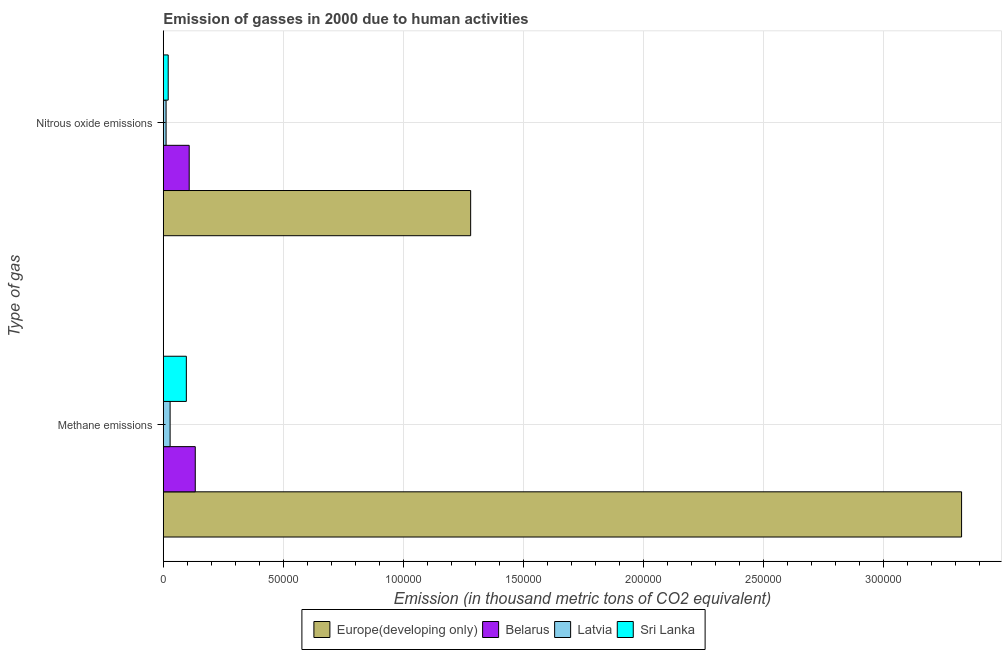Are the number of bars per tick equal to the number of legend labels?
Offer a very short reply. Yes. How many bars are there on the 2nd tick from the top?
Make the answer very short. 4. How many bars are there on the 1st tick from the bottom?
Offer a terse response. 4. What is the label of the 1st group of bars from the top?
Make the answer very short. Nitrous oxide emissions. What is the amount of nitrous oxide emissions in Belarus?
Your answer should be very brief. 1.08e+04. Across all countries, what is the maximum amount of nitrous oxide emissions?
Provide a succinct answer. 1.28e+05. Across all countries, what is the minimum amount of methane emissions?
Offer a very short reply. 2840. In which country was the amount of nitrous oxide emissions maximum?
Provide a succinct answer. Europe(developing only). In which country was the amount of nitrous oxide emissions minimum?
Your answer should be compact. Latvia. What is the total amount of methane emissions in the graph?
Offer a very short reply. 3.59e+05. What is the difference between the amount of methane emissions in Sri Lanka and that in Latvia?
Offer a terse response. 6767.2. What is the difference between the amount of nitrous oxide emissions in Europe(developing only) and the amount of methane emissions in Latvia?
Your answer should be very brief. 1.25e+05. What is the average amount of nitrous oxide emissions per country?
Your answer should be compact. 3.55e+04. What is the difference between the amount of methane emissions and amount of nitrous oxide emissions in Europe(developing only)?
Ensure brevity in your answer.  2.05e+05. In how many countries, is the amount of methane emissions greater than 220000 thousand metric tons?
Your response must be concise. 1. What is the ratio of the amount of methane emissions in Latvia to that in Belarus?
Your answer should be compact. 0.21. What does the 3rd bar from the top in Nitrous oxide emissions represents?
Provide a short and direct response. Belarus. What does the 2nd bar from the bottom in Nitrous oxide emissions represents?
Ensure brevity in your answer.  Belarus. How many bars are there?
Your answer should be very brief. 8. What is the difference between two consecutive major ticks on the X-axis?
Make the answer very short. 5.00e+04. Are the values on the major ticks of X-axis written in scientific E-notation?
Offer a very short reply. No. How many legend labels are there?
Keep it short and to the point. 4. How are the legend labels stacked?
Provide a short and direct response. Horizontal. What is the title of the graph?
Your answer should be very brief. Emission of gasses in 2000 due to human activities. Does "Iraq" appear as one of the legend labels in the graph?
Provide a succinct answer. No. What is the label or title of the X-axis?
Your answer should be compact. Emission (in thousand metric tons of CO2 equivalent). What is the label or title of the Y-axis?
Provide a succinct answer. Type of gas. What is the Emission (in thousand metric tons of CO2 equivalent) in Europe(developing only) in Methane emissions?
Offer a terse response. 3.33e+05. What is the Emission (in thousand metric tons of CO2 equivalent) in Belarus in Methane emissions?
Give a very brief answer. 1.33e+04. What is the Emission (in thousand metric tons of CO2 equivalent) of Latvia in Methane emissions?
Provide a short and direct response. 2840. What is the Emission (in thousand metric tons of CO2 equivalent) in Sri Lanka in Methane emissions?
Your response must be concise. 9607.2. What is the Emission (in thousand metric tons of CO2 equivalent) of Europe(developing only) in Nitrous oxide emissions?
Your answer should be compact. 1.28e+05. What is the Emission (in thousand metric tons of CO2 equivalent) in Belarus in Nitrous oxide emissions?
Provide a succinct answer. 1.08e+04. What is the Emission (in thousand metric tons of CO2 equivalent) in Latvia in Nitrous oxide emissions?
Provide a short and direct response. 1159.4. What is the Emission (in thousand metric tons of CO2 equivalent) of Sri Lanka in Nitrous oxide emissions?
Your answer should be compact. 2044.5. Across all Type of gas, what is the maximum Emission (in thousand metric tons of CO2 equivalent) in Europe(developing only)?
Provide a short and direct response. 3.33e+05. Across all Type of gas, what is the maximum Emission (in thousand metric tons of CO2 equivalent) of Belarus?
Your answer should be very brief. 1.33e+04. Across all Type of gas, what is the maximum Emission (in thousand metric tons of CO2 equivalent) of Latvia?
Offer a terse response. 2840. Across all Type of gas, what is the maximum Emission (in thousand metric tons of CO2 equivalent) in Sri Lanka?
Provide a short and direct response. 9607.2. Across all Type of gas, what is the minimum Emission (in thousand metric tons of CO2 equivalent) of Europe(developing only)?
Provide a succinct answer. 1.28e+05. Across all Type of gas, what is the minimum Emission (in thousand metric tons of CO2 equivalent) in Belarus?
Keep it short and to the point. 1.08e+04. Across all Type of gas, what is the minimum Emission (in thousand metric tons of CO2 equivalent) in Latvia?
Give a very brief answer. 1159.4. Across all Type of gas, what is the minimum Emission (in thousand metric tons of CO2 equivalent) in Sri Lanka?
Ensure brevity in your answer.  2044.5. What is the total Emission (in thousand metric tons of CO2 equivalent) of Europe(developing only) in the graph?
Ensure brevity in your answer.  4.61e+05. What is the total Emission (in thousand metric tons of CO2 equivalent) of Belarus in the graph?
Offer a terse response. 2.41e+04. What is the total Emission (in thousand metric tons of CO2 equivalent) in Latvia in the graph?
Your answer should be very brief. 3999.4. What is the total Emission (in thousand metric tons of CO2 equivalent) of Sri Lanka in the graph?
Keep it short and to the point. 1.17e+04. What is the difference between the Emission (in thousand metric tons of CO2 equivalent) of Europe(developing only) in Methane emissions and that in Nitrous oxide emissions?
Ensure brevity in your answer.  2.05e+05. What is the difference between the Emission (in thousand metric tons of CO2 equivalent) of Belarus in Methane emissions and that in Nitrous oxide emissions?
Offer a terse response. 2527.5. What is the difference between the Emission (in thousand metric tons of CO2 equivalent) in Latvia in Methane emissions and that in Nitrous oxide emissions?
Offer a terse response. 1680.6. What is the difference between the Emission (in thousand metric tons of CO2 equivalent) of Sri Lanka in Methane emissions and that in Nitrous oxide emissions?
Give a very brief answer. 7562.7. What is the difference between the Emission (in thousand metric tons of CO2 equivalent) in Europe(developing only) in Methane emissions and the Emission (in thousand metric tons of CO2 equivalent) in Belarus in Nitrous oxide emissions?
Your response must be concise. 3.22e+05. What is the difference between the Emission (in thousand metric tons of CO2 equivalent) of Europe(developing only) in Methane emissions and the Emission (in thousand metric tons of CO2 equivalent) of Latvia in Nitrous oxide emissions?
Make the answer very short. 3.32e+05. What is the difference between the Emission (in thousand metric tons of CO2 equivalent) of Europe(developing only) in Methane emissions and the Emission (in thousand metric tons of CO2 equivalent) of Sri Lanka in Nitrous oxide emissions?
Your response must be concise. 3.31e+05. What is the difference between the Emission (in thousand metric tons of CO2 equivalent) in Belarus in Methane emissions and the Emission (in thousand metric tons of CO2 equivalent) in Latvia in Nitrous oxide emissions?
Give a very brief answer. 1.22e+04. What is the difference between the Emission (in thousand metric tons of CO2 equivalent) of Belarus in Methane emissions and the Emission (in thousand metric tons of CO2 equivalent) of Sri Lanka in Nitrous oxide emissions?
Give a very brief answer. 1.13e+04. What is the difference between the Emission (in thousand metric tons of CO2 equivalent) of Latvia in Methane emissions and the Emission (in thousand metric tons of CO2 equivalent) of Sri Lanka in Nitrous oxide emissions?
Offer a very short reply. 795.5. What is the average Emission (in thousand metric tons of CO2 equivalent) in Europe(developing only) per Type of gas?
Give a very brief answer. 2.30e+05. What is the average Emission (in thousand metric tons of CO2 equivalent) of Belarus per Type of gas?
Give a very brief answer. 1.21e+04. What is the average Emission (in thousand metric tons of CO2 equivalent) of Latvia per Type of gas?
Provide a succinct answer. 1999.7. What is the average Emission (in thousand metric tons of CO2 equivalent) in Sri Lanka per Type of gas?
Offer a terse response. 5825.85. What is the difference between the Emission (in thousand metric tons of CO2 equivalent) in Europe(developing only) and Emission (in thousand metric tons of CO2 equivalent) in Belarus in Methane emissions?
Your answer should be very brief. 3.19e+05. What is the difference between the Emission (in thousand metric tons of CO2 equivalent) of Europe(developing only) and Emission (in thousand metric tons of CO2 equivalent) of Latvia in Methane emissions?
Provide a succinct answer. 3.30e+05. What is the difference between the Emission (in thousand metric tons of CO2 equivalent) of Europe(developing only) and Emission (in thousand metric tons of CO2 equivalent) of Sri Lanka in Methane emissions?
Keep it short and to the point. 3.23e+05. What is the difference between the Emission (in thousand metric tons of CO2 equivalent) of Belarus and Emission (in thousand metric tons of CO2 equivalent) of Latvia in Methane emissions?
Offer a terse response. 1.05e+04. What is the difference between the Emission (in thousand metric tons of CO2 equivalent) of Belarus and Emission (in thousand metric tons of CO2 equivalent) of Sri Lanka in Methane emissions?
Offer a terse response. 3716.2. What is the difference between the Emission (in thousand metric tons of CO2 equivalent) of Latvia and Emission (in thousand metric tons of CO2 equivalent) of Sri Lanka in Methane emissions?
Ensure brevity in your answer.  -6767.2. What is the difference between the Emission (in thousand metric tons of CO2 equivalent) of Europe(developing only) and Emission (in thousand metric tons of CO2 equivalent) of Belarus in Nitrous oxide emissions?
Make the answer very short. 1.17e+05. What is the difference between the Emission (in thousand metric tons of CO2 equivalent) of Europe(developing only) and Emission (in thousand metric tons of CO2 equivalent) of Latvia in Nitrous oxide emissions?
Give a very brief answer. 1.27e+05. What is the difference between the Emission (in thousand metric tons of CO2 equivalent) in Europe(developing only) and Emission (in thousand metric tons of CO2 equivalent) in Sri Lanka in Nitrous oxide emissions?
Make the answer very short. 1.26e+05. What is the difference between the Emission (in thousand metric tons of CO2 equivalent) in Belarus and Emission (in thousand metric tons of CO2 equivalent) in Latvia in Nitrous oxide emissions?
Provide a succinct answer. 9636.5. What is the difference between the Emission (in thousand metric tons of CO2 equivalent) of Belarus and Emission (in thousand metric tons of CO2 equivalent) of Sri Lanka in Nitrous oxide emissions?
Give a very brief answer. 8751.4. What is the difference between the Emission (in thousand metric tons of CO2 equivalent) of Latvia and Emission (in thousand metric tons of CO2 equivalent) of Sri Lanka in Nitrous oxide emissions?
Keep it short and to the point. -885.1. What is the ratio of the Emission (in thousand metric tons of CO2 equivalent) of Europe(developing only) in Methane emissions to that in Nitrous oxide emissions?
Offer a terse response. 2.6. What is the ratio of the Emission (in thousand metric tons of CO2 equivalent) in Belarus in Methane emissions to that in Nitrous oxide emissions?
Provide a short and direct response. 1.23. What is the ratio of the Emission (in thousand metric tons of CO2 equivalent) in Latvia in Methane emissions to that in Nitrous oxide emissions?
Ensure brevity in your answer.  2.45. What is the ratio of the Emission (in thousand metric tons of CO2 equivalent) of Sri Lanka in Methane emissions to that in Nitrous oxide emissions?
Offer a terse response. 4.7. What is the difference between the highest and the second highest Emission (in thousand metric tons of CO2 equivalent) of Europe(developing only)?
Ensure brevity in your answer.  2.05e+05. What is the difference between the highest and the second highest Emission (in thousand metric tons of CO2 equivalent) of Belarus?
Your response must be concise. 2527.5. What is the difference between the highest and the second highest Emission (in thousand metric tons of CO2 equivalent) of Latvia?
Your answer should be compact. 1680.6. What is the difference between the highest and the second highest Emission (in thousand metric tons of CO2 equivalent) in Sri Lanka?
Your answer should be very brief. 7562.7. What is the difference between the highest and the lowest Emission (in thousand metric tons of CO2 equivalent) in Europe(developing only)?
Your answer should be very brief. 2.05e+05. What is the difference between the highest and the lowest Emission (in thousand metric tons of CO2 equivalent) of Belarus?
Your response must be concise. 2527.5. What is the difference between the highest and the lowest Emission (in thousand metric tons of CO2 equivalent) of Latvia?
Offer a terse response. 1680.6. What is the difference between the highest and the lowest Emission (in thousand metric tons of CO2 equivalent) in Sri Lanka?
Offer a very short reply. 7562.7. 